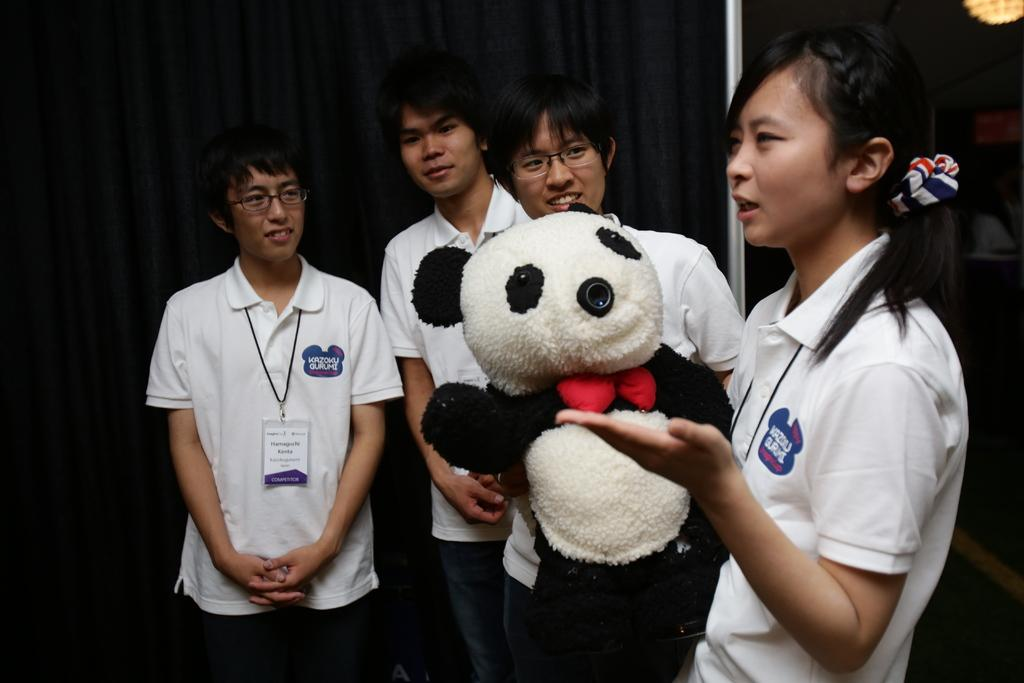What are the people in the image doing? The people in the image are standing. What is the woman holding in the image? The woman is holding a doll in the image. How would you describe the lighting in the image? There is light in the image. What can be seen in the background of the image? The background of the image is dark, and there is a curtain visible. How many chairs are visible in the image? There are no chairs visible in the image. What type of stick is the woman using to hold the doll? The woman is not using a stick to hold the doll; she is simply holding it in her hands. 